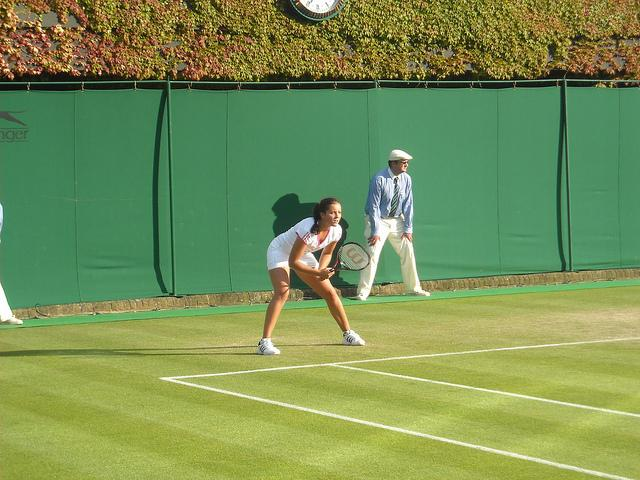Which shadow is the longest? woman 